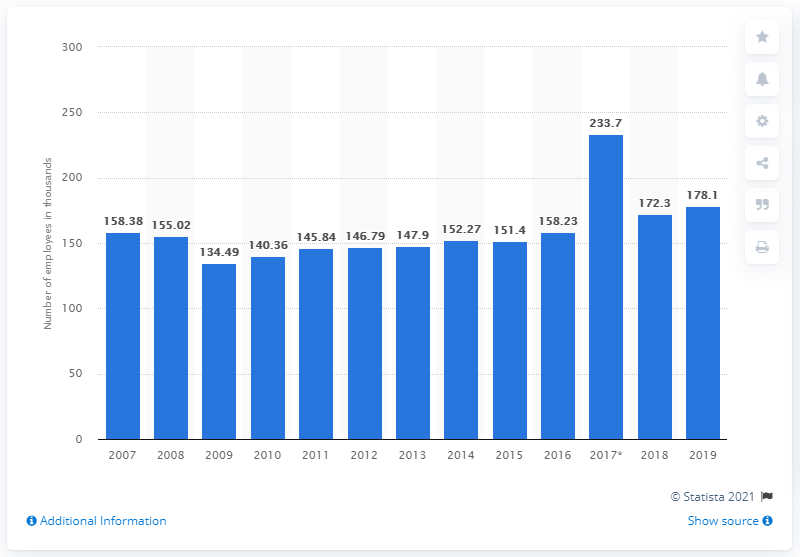Give some essential details in this illustration. In the year 2007, the cruise industry employed 178 thousand people. 